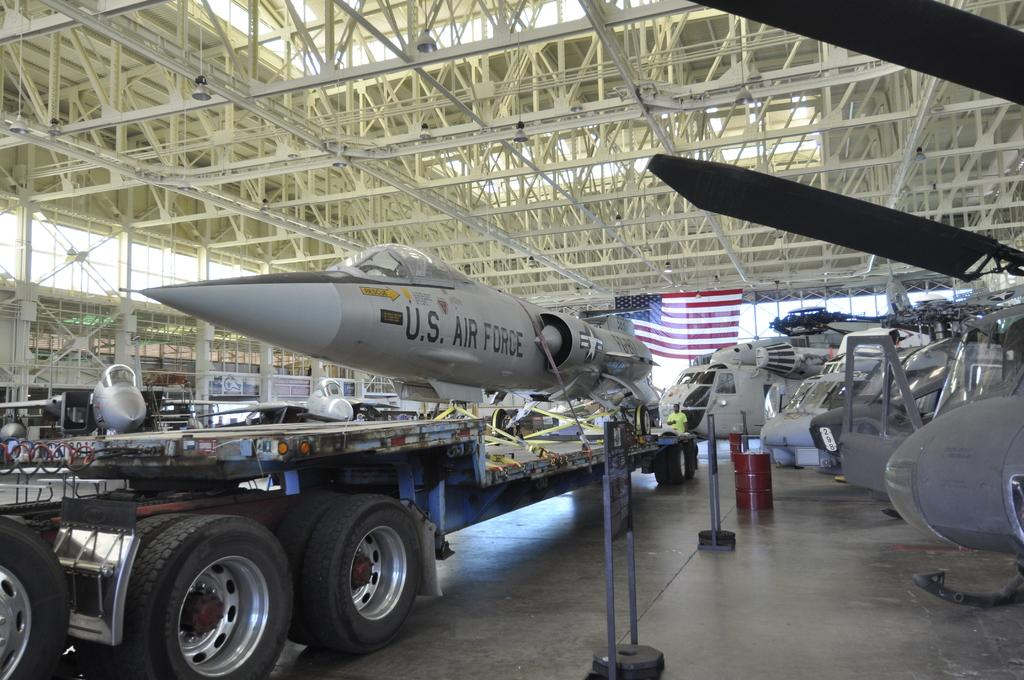<image>
Render a clear and concise summary of the photo. A fighter jet with US Airforce logo on the side is on the truck bed. 